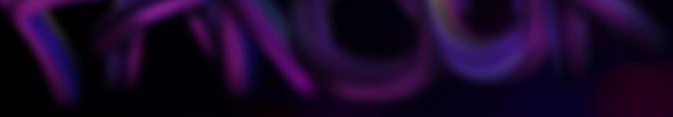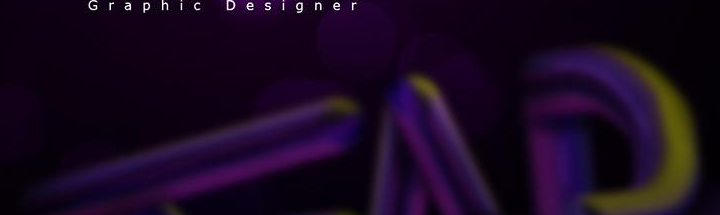What words can you see in these images in sequence, separated by a semicolon? ######; ### 